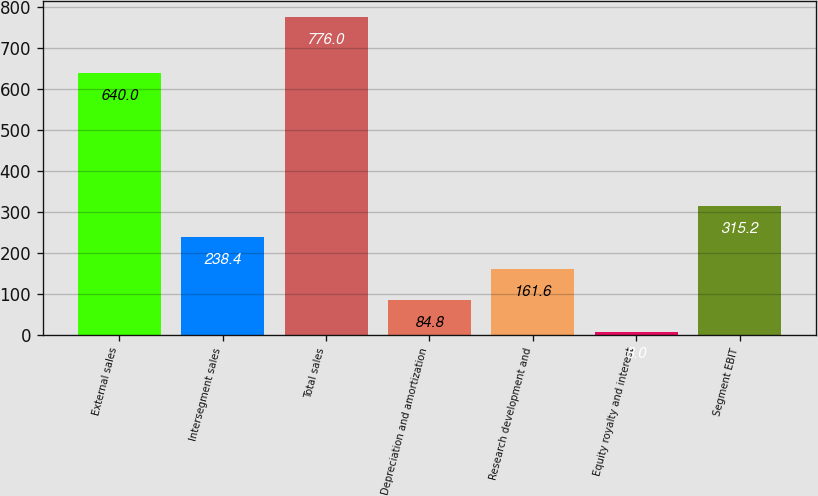<chart> <loc_0><loc_0><loc_500><loc_500><bar_chart><fcel>External sales<fcel>Intersegment sales<fcel>Total sales<fcel>Depreciation and amortization<fcel>Research development and<fcel>Equity royalty and interest<fcel>Segment EBIT<nl><fcel>640<fcel>238.4<fcel>776<fcel>84.8<fcel>161.6<fcel>8<fcel>315.2<nl></chart> 